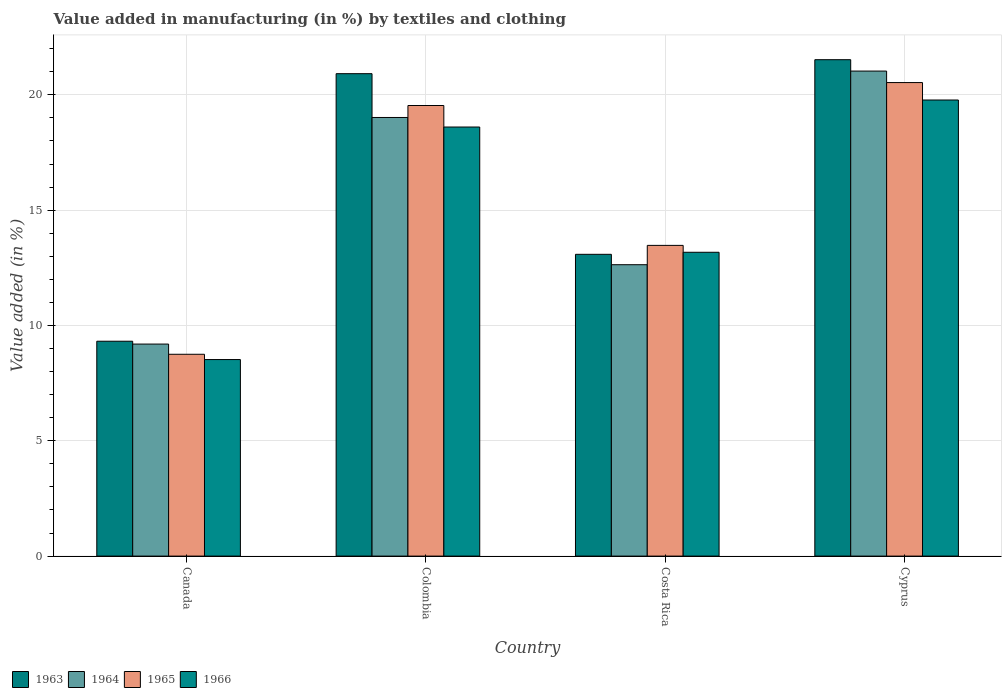How many different coloured bars are there?
Keep it short and to the point. 4. How many groups of bars are there?
Ensure brevity in your answer.  4. Are the number of bars per tick equal to the number of legend labels?
Provide a succinct answer. Yes. How many bars are there on the 3rd tick from the left?
Your response must be concise. 4. How many bars are there on the 2nd tick from the right?
Ensure brevity in your answer.  4. What is the percentage of value added in manufacturing by textiles and clothing in 1965 in Cyprus?
Your answer should be compact. 20.53. Across all countries, what is the maximum percentage of value added in manufacturing by textiles and clothing in 1964?
Your answer should be very brief. 21.03. Across all countries, what is the minimum percentage of value added in manufacturing by textiles and clothing in 1964?
Your response must be concise. 9.19. In which country was the percentage of value added in manufacturing by textiles and clothing in 1963 maximum?
Your answer should be compact. Cyprus. What is the total percentage of value added in manufacturing by textiles and clothing in 1964 in the graph?
Give a very brief answer. 61.88. What is the difference between the percentage of value added in manufacturing by textiles and clothing in 1963 in Canada and that in Colombia?
Your answer should be very brief. -11.6. What is the difference between the percentage of value added in manufacturing by textiles and clothing in 1964 in Canada and the percentage of value added in manufacturing by textiles and clothing in 1963 in Colombia?
Your response must be concise. -11.72. What is the average percentage of value added in manufacturing by textiles and clothing in 1966 per country?
Your answer should be very brief. 15.02. What is the difference between the percentage of value added in manufacturing by textiles and clothing of/in 1965 and percentage of value added in manufacturing by textiles and clothing of/in 1964 in Cyprus?
Your response must be concise. -0.5. In how many countries, is the percentage of value added in manufacturing by textiles and clothing in 1964 greater than 21 %?
Keep it short and to the point. 1. What is the ratio of the percentage of value added in manufacturing by textiles and clothing in 1963 in Canada to that in Cyprus?
Keep it short and to the point. 0.43. What is the difference between the highest and the second highest percentage of value added in manufacturing by textiles and clothing in 1965?
Your answer should be very brief. -0.99. What is the difference between the highest and the lowest percentage of value added in manufacturing by textiles and clothing in 1963?
Make the answer very short. 12.21. In how many countries, is the percentage of value added in manufacturing by textiles and clothing in 1964 greater than the average percentage of value added in manufacturing by textiles and clothing in 1964 taken over all countries?
Ensure brevity in your answer.  2. Is it the case that in every country, the sum of the percentage of value added in manufacturing by textiles and clothing in 1966 and percentage of value added in manufacturing by textiles and clothing in 1964 is greater than the sum of percentage of value added in manufacturing by textiles and clothing in 1965 and percentage of value added in manufacturing by textiles and clothing in 1963?
Give a very brief answer. No. What does the 3rd bar from the left in Costa Rica represents?
Your response must be concise. 1965. What does the 3rd bar from the right in Colombia represents?
Offer a terse response. 1964. Is it the case that in every country, the sum of the percentage of value added in manufacturing by textiles and clothing in 1963 and percentage of value added in manufacturing by textiles and clothing in 1966 is greater than the percentage of value added in manufacturing by textiles and clothing in 1964?
Provide a short and direct response. Yes. What is the difference between two consecutive major ticks on the Y-axis?
Your answer should be very brief. 5. Are the values on the major ticks of Y-axis written in scientific E-notation?
Your response must be concise. No. How many legend labels are there?
Your answer should be compact. 4. What is the title of the graph?
Make the answer very short. Value added in manufacturing (in %) by textiles and clothing. Does "1973" appear as one of the legend labels in the graph?
Make the answer very short. No. What is the label or title of the X-axis?
Your response must be concise. Country. What is the label or title of the Y-axis?
Offer a terse response. Value added (in %). What is the Value added (in %) of 1963 in Canada?
Your response must be concise. 9.32. What is the Value added (in %) of 1964 in Canada?
Offer a very short reply. 9.19. What is the Value added (in %) in 1965 in Canada?
Give a very brief answer. 8.75. What is the Value added (in %) of 1966 in Canada?
Make the answer very short. 8.52. What is the Value added (in %) of 1963 in Colombia?
Give a very brief answer. 20.92. What is the Value added (in %) in 1964 in Colombia?
Keep it short and to the point. 19.02. What is the Value added (in %) of 1965 in Colombia?
Offer a terse response. 19.54. What is the Value added (in %) of 1966 in Colombia?
Make the answer very short. 18.6. What is the Value added (in %) of 1963 in Costa Rica?
Your response must be concise. 13.08. What is the Value added (in %) of 1964 in Costa Rica?
Give a very brief answer. 12.63. What is the Value added (in %) in 1965 in Costa Rica?
Give a very brief answer. 13.47. What is the Value added (in %) of 1966 in Costa Rica?
Provide a succinct answer. 13.17. What is the Value added (in %) of 1963 in Cyprus?
Make the answer very short. 21.52. What is the Value added (in %) in 1964 in Cyprus?
Give a very brief answer. 21.03. What is the Value added (in %) of 1965 in Cyprus?
Your response must be concise. 20.53. What is the Value added (in %) in 1966 in Cyprus?
Make the answer very short. 19.78. Across all countries, what is the maximum Value added (in %) of 1963?
Your answer should be very brief. 21.52. Across all countries, what is the maximum Value added (in %) in 1964?
Ensure brevity in your answer.  21.03. Across all countries, what is the maximum Value added (in %) in 1965?
Provide a short and direct response. 20.53. Across all countries, what is the maximum Value added (in %) of 1966?
Your answer should be very brief. 19.78. Across all countries, what is the minimum Value added (in %) of 1963?
Your answer should be very brief. 9.32. Across all countries, what is the minimum Value added (in %) of 1964?
Your response must be concise. 9.19. Across all countries, what is the minimum Value added (in %) of 1965?
Your response must be concise. 8.75. Across all countries, what is the minimum Value added (in %) in 1966?
Make the answer very short. 8.52. What is the total Value added (in %) of 1963 in the graph?
Make the answer very short. 64.84. What is the total Value added (in %) in 1964 in the graph?
Ensure brevity in your answer.  61.88. What is the total Value added (in %) of 1965 in the graph?
Make the answer very short. 62.29. What is the total Value added (in %) of 1966 in the graph?
Your response must be concise. 60.08. What is the difference between the Value added (in %) in 1963 in Canada and that in Colombia?
Offer a terse response. -11.6. What is the difference between the Value added (in %) of 1964 in Canada and that in Colombia?
Offer a very short reply. -9.82. What is the difference between the Value added (in %) in 1965 in Canada and that in Colombia?
Give a very brief answer. -10.79. What is the difference between the Value added (in %) in 1966 in Canada and that in Colombia?
Offer a terse response. -10.08. What is the difference between the Value added (in %) of 1963 in Canada and that in Costa Rica?
Keep it short and to the point. -3.77. What is the difference between the Value added (in %) in 1964 in Canada and that in Costa Rica?
Your answer should be very brief. -3.44. What is the difference between the Value added (in %) of 1965 in Canada and that in Costa Rica?
Ensure brevity in your answer.  -4.72. What is the difference between the Value added (in %) in 1966 in Canada and that in Costa Rica?
Your answer should be compact. -4.65. What is the difference between the Value added (in %) of 1963 in Canada and that in Cyprus?
Provide a succinct answer. -12.21. What is the difference between the Value added (in %) of 1964 in Canada and that in Cyprus?
Ensure brevity in your answer.  -11.84. What is the difference between the Value added (in %) in 1965 in Canada and that in Cyprus?
Your answer should be compact. -11.78. What is the difference between the Value added (in %) of 1966 in Canada and that in Cyprus?
Keep it short and to the point. -11.25. What is the difference between the Value added (in %) of 1963 in Colombia and that in Costa Rica?
Offer a terse response. 7.83. What is the difference between the Value added (in %) in 1964 in Colombia and that in Costa Rica?
Provide a short and direct response. 6.38. What is the difference between the Value added (in %) of 1965 in Colombia and that in Costa Rica?
Provide a short and direct response. 6.06. What is the difference between the Value added (in %) in 1966 in Colombia and that in Costa Rica?
Your answer should be compact. 5.43. What is the difference between the Value added (in %) of 1963 in Colombia and that in Cyprus?
Provide a short and direct response. -0.61. What is the difference between the Value added (in %) of 1964 in Colombia and that in Cyprus?
Ensure brevity in your answer.  -2.01. What is the difference between the Value added (in %) in 1965 in Colombia and that in Cyprus?
Your answer should be compact. -0.99. What is the difference between the Value added (in %) of 1966 in Colombia and that in Cyprus?
Make the answer very short. -1.17. What is the difference between the Value added (in %) of 1963 in Costa Rica and that in Cyprus?
Make the answer very short. -8.44. What is the difference between the Value added (in %) in 1964 in Costa Rica and that in Cyprus?
Offer a very short reply. -8.4. What is the difference between the Value added (in %) in 1965 in Costa Rica and that in Cyprus?
Provide a succinct answer. -7.06. What is the difference between the Value added (in %) of 1966 in Costa Rica and that in Cyprus?
Your answer should be very brief. -6.6. What is the difference between the Value added (in %) in 1963 in Canada and the Value added (in %) in 1964 in Colombia?
Offer a terse response. -9.7. What is the difference between the Value added (in %) of 1963 in Canada and the Value added (in %) of 1965 in Colombia?
Your response must be concise. -10.22. What is the difference between the Value added (in %) in 1963 in Canada and the Value added (in %) in 1966 in Colombia?
Give a very brief answer. -9.29. What is the difference between the Value added (in %) of 1964 in Canada and the Value added (in %) of 1965 in Colombia?
Offer a very short reply. -10.34. What is the difference between the Value added (in %) of 1964 in Canada and the Value added (in %) of 1966 in Colombia?
Your response must be concise. -9.41. What is the difference between the Value added (in %) of 1965 in Canada and the Value added (in %) of 1966 in Colombia?
Provide a short and direct response. -9.85. What is the difference between the Value added (in %) of 1963 in Canada and the Value added (in %) of 1964 in Costa Rica?
Provide a succinct answer. -3.32. What is the difference between the Value added (in %) in 1963 in Canada and the Value added (in %) in 1965 in Costa Rica?
Provide a short and direct response. -4.16. What is the difference between the Value added (in %) of 1963 in Canada and the Value added (in %) of 1966 in Costa Rica?
Your answer should be compact. -3.86. What is the difference between the Value added (in %) of 1964 in Canada and the Value added (in %) of 1965 in Costa Rica?
Give a very brief answer. -4.28. What is the difference between the Value added (in %) in 1964 in Canada and the Value added (in %) in 1966 in Costa Rica?
Offer a very short reply. -3.98. What is the difference between the Value added (in %) of 1965 in Canada and the Value added (in %) of 1966 in Costa Rica?
Your answer should be compact. -4.42. What is the difference between the Value added (in %) of 1963 in Canada and the Value added (in %) of 1964 in Cyprus?
Your answer should be very brief. -11.71. What is the difference between the Value added (in %) in 1963 in Canada and the Value added (in %) in 1965 in Cyprus?
Keep it short and to the point. -11.21. What is the difference between the Value added (in %) in 1963 in Canada and the Value added (in %) in 1966 in Cyprus?
Provide a short and direct response. -10.46. What is the difference between the Value added (in %) of 1964 in Canada and the Value added (in %) of 1965 in Cyprus?
Give a very brief answer. -11.34. What is the difference between the Value added (in %) in 1964 in Canada and the Value added (in %) in 1966 in Cyprus?
Give a very brief answer. -10.58. What is the difference between the Value added (in %) of 1965 in Canada and the Value added (in %) of 1966 in Cyprus?
Your response must be concise. -11.02. What is the difference between the Value added (in %) in 1963 in Colombia and the Value added (in %) in 1964 in Costa Rica?
Provide a short and direct response. 8.28. What is the difference between the Value added (in %) of 1963 in Colombia and the Value added (in %) of 1965 in Costa Rica?
Provide a short and direct response. 7.44. What is the difference between the Value added (in %) in 1963 in Colombia and the Value added (in %) in 1966 in Costa Rica?
Make the answer very short. 7.74. What is the difference between the Value added (in %) in 1964 in Colombia and the Value added (in %) in 1965 in Costa Rica?
Offer a very short reply. 5.55. What is the difference between the Value added (in %) of 1964 in Colombia and the Value added (in %) of 1966 in Costa Rica?
Offer a very short reply. 5.84. What is the difference between the Value added (in %) of 1965 in Colombia and the Value added (in %) of 1966 in Costa Rica?
Keep it short and to the point. 6.36. What is the difference between the Value added (in %) in 1963 in Colombia and the Value added (in %) in 1964 in Cyprus?
Your answer should be very brief. -0.11. What is the difference between the Value added (in %) of 1963 in Colombia and the Value added (in %) of 1965 in Cyprus?
Give a very brief answer. 0.39. What is the difference between the Value added (in %) in 1963 in Colombia and the Value added (in %) in 1966 in Cyprus?
Offer a very short reply. 1.14. What is the difference between the Value added (in %) of 1964 in Colombia and the Value added (in %) of 1965 in Cyprus?
Make the answer very short. -1.51. What is the difference between the Value added (in %) in 1964 in Colombia and the Value added (in %) in 1966 in Cyprus?
Provide a short and direct response. -0.76. What is the difference between the Value added (in %) of 1965 in Colombia and the Value added (in %) of 1966 in Cyprus?
Keep it short and to the point. -0.24. What is the difference between the Value added (in %) in 1963 in Costa Rica and the Value added (in %) in 1964 in Cyprus?
Give a very brief answer. -7.95. What is the difference between the Value added (in %) in 1963 in Costa Rica and the Value added (in %) in 1965 in Cyprus?
Give a very brief answer. -7.45. What is the difference between the Value added (in %) in 1963 in Costa Rica and the Value added (in %) in 1966 in Cyprus?
Provide a succinct answer. -6.69. What is the difference between the Value added (in %) of 1964 in Costa Rica and the Value added (in %) of 1965 in Cyprus?
Offer a terse response. -7.9. What is the difference between the Value added (in %) in 1964 in Costa Rica and the Value added (in %) in 1966 in Cyprus?
Your answer should be very brief. -7.14. What is the difference between the Value added (in %) in 1965 in Costa Rica and the Value added (in %) in 1966 in Cyprus?
Provide a short and direct response. -6.3. What is the average Value added (in %) of 1963 per country?
Your response must be concise. 16.21. What is the average Value added (in %) of 1964 per country?
Provide a short and direct response. 15.47. What is the average Value added (in %) in 1965 per country?
Offer a terse response. 15.57. What is the average Value added (in %) in 1966 per country?
Keep it short and to the point. 15.02. What is the difference between the Value added (in %) in 1963 and Value added (in %) in 1964 in Canada?
Your answer should be compact. 0.12. What is the difference between the Value added (in %) in 1963 and Value added (in %) in 1965 in Canada?
Your answer should be very brief. 0.57. What is the difference between the Value added (in %) in 1963 and Value added (in %) in 1966 in Canada?
Keep it short and to the point. 0.8. What is the difference between the Value added (in %) of 1964 and Value added (in %) of 1965 in Canada?
Provide a short and direct response. 0.44. What is the difference between the Value added (in %) in 1964 and Value added (in %) in 1966 in Canada?
Make the answer very short. 0.67. What is the difference between the Value added (in %) of 1965 and Value added (in %) of 1966 in Canada?
Provide a short and direct response. 0.23. What is the difference between the Value added (in %) in 1963 and Value added (in %) in 1964 in Colombia?
Offer a very short reply. 1.9. What is the difference between the Value added (in %) of 1963 and Value added (in %) of 1965 in Colombia?
Provide a short and direct response. 1.38. What is the difference between the Value added (in %) of 1963 and Value added (in %) of 1966 in Colombia?
Offer a terse response. 2.31. What is the difference between the Value added (in %) of 1964 and Value added (in %) of 1965 in Colombia?
Provide a succinct answer. -0.52. What is the difference between the Value added (in %) of 1964 and Value added (in %) of 1966 in Colombia?
Make the answer very short. 0.41. What is the difference between the Value added (in %) of 1965 and Value added (in %) of 1966 in Colombia?
Your answer should be compact. 0.93. What is the difference between the Value added (in %) in 1963 and Value added (in %) in 1964 in Costa Rica?
Ensure brevity in your answer.  0.45. What is the difference between the Value added (in %) in 1963 and Value added (in %) in 1965 in Costa Rica?
Your response must be concise. -0.39. What is the difference between the Value added (in %) in 1963 and Value added (in %) in 1966 in Costa Rica?
Offer a terse response. -0.09. What is the difference between the Value added (in %) of 1964 and Value added (in %) of 1965 in Costa Rica?
Offer a very short reply. -0.84. What is the difference between the Value added (in %) of 1964 and Value added (in %) of 1966 in Costa Rica?
Keep it short and to the point. -0.54. What is the difference between the Value added (in %) in 1965 and Value added (in %) in 1966 in Costa Rica?
Keep it short and to the point. 0.3. What is the difference between the Value added (in %) in 1963 and Value added (in %) in 1964 in Cyprus?
Keep it short and to the point. 0.49. What is the difference between the Value added (in %) in 1963 and Value added (in %) in 1966 in Cyprus?
Your response must be concise. 1.75. What is the difference between the Value added (in %) in 1964 and Value added (in %) in 1965 in Cyprus?
Offer a terse response. 0.5. What is the difference between the Value added (in %) in 1964 and Value added (in %) in 1966 in Cyprus?
Your answer should be compact. 1.25. What is the difference between the Value added (in %) of 1965 and Value added (in %) of 1966 in Cyprus?
Your answer should be compact. 0.76. What is the ratio of the Value added (in %) of 1963 in Canada to that in Colombia?
Your answer should be very brief. 0.45. What is the ratio of the Value added (in %) in 1964 in Canada to that in Colombia?
Make the answer very short. 0.48. What is the ratio of the Value added (in %) of 1965 in Canada to that in Colombia?
Your answer should be very brief. 0.45. What is the ratio of the Value added (in %) of 1966 in Canada to that in Colombia?
Your answer should be very brief. 0.46. What is the ratio of the Value added (in %) of 1963 in Canada to that in Costa Rica?
Your answer should be compact. 0.71. What is the ratio of the Value added (in %) in 1964 in Canada to that in Costa Rica?
Make the answer very short. 0.73. What is the ratio of the Value added (in %) in 1965 in Canada to that in Costa Rica?
Offer a terse response. 0.65. What is the ratio of the Value added (in %) of 1966 in Canada to that in Costa Rica?
Keep it short and to the point. 0.65. What is the ratio of the Value added (in %) in 1963 in Canada to that in Cyprus?
Your answer should be compact. 0.43. What is the ratio of the Value added (in %) of 1964 in Canada to that in Cyprus?
Ensure brevity in your answer.  0.44. What is the ratio of the Value added (in %) of 1965 in Canada to that in Cyprus?
Offer a terse response. 0.43. What is the ratio of the Value added (in %) of 1966 in Canada to that in Cyprus?
Make the answer very short. 0.43. What is the ratio of the Value added (in %) in 1963 in Colombia to that in Costa Rica?
Offer a very short reply. 1.6. What is the ratio of the Value added (in %) of 1964 in Colombia to that in Costa Rica?
Your response must be concise. 1.51. What is the ratio of the Value added (in %) of 1965 in Colombia to that in Costa Rica?
Ensure brevity in your answer.  1.45. What is the ratio of the Value added (in %) in 1966 in Colombia to that in Costa Rica?
Provide a succinct answer. 1.41. What is the ratio of the Value added (in %) of 1963 in Colombia to that in Cyprus?
Ensure brevity in your answer.  0.97. What is the ratio of the Value added (in %) in 1964 in Colombia to that in Cyprus?
Provide a short and direct response. 0.9. What is the ratio of the Value added (in %) in 1965 in Colombia to that in Cyprus?
Provide a succinct answer. 0.95. What is the ratio of the Value added (in %) in 1966 in Colombia to that in Cyprus?
Offer a terse response. 0.94. What is the ratio of the Value added (in %) of 1963 in Costa Rica to that in Cyprus?
Ensure brevity in your answer.  0.61. What is the ratio of the Value added (in %) in 1964 in Costa Rica to that in Cyprus?
Your response must be concise. 0.6. What is the ratio of the Value added (in %) of 1965 in Costa Rica to that in Cyprus?
Provide a succinct answer. 0.66. What is the ratio of the Value added (in %) of 1966 in Costa Rica to that in Cyprus?
Ensure brevity in your answer.  0.67. What is the difference between the highest and the second highest Value added (in %) in 1963?
Keep it short and to the point. 0.61. What is the difference between the highest and the second highest Value added (in %) in 1964?
Keep it short and to the point. 2.01. What is the difference between the highest and the second highest Value added (in %) of 1965?
Ensure brevity in your answer.  0.99. What is the difference between the highest and the second highest Value added (in %) of 1966?
Provide a succinct answer. 1.17. What is the difference between the highest and the lowest Value added (in %) of 1963?
Offer a terse response. 12.21. What is the difference between the highest and the lowest Value added (in %) in 1964?
Provide a short and direct response. 11.84. What is the difference between the highest and the lowest Value added (in %) of 1965?
Ensure brevity in your answer.  11.78. What is the difference between the highest and the lowest Value added (in %) of 1966?
Give a very brief answer. 11.25. 